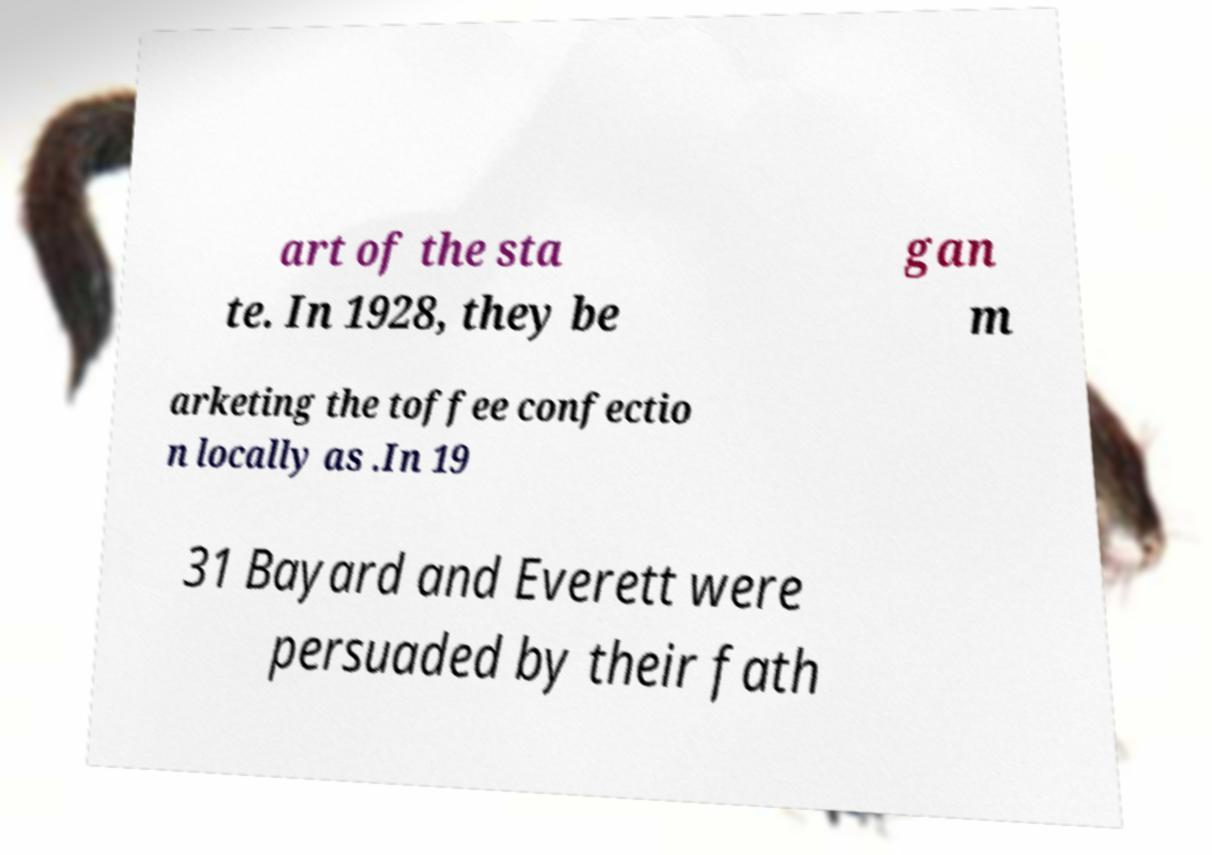Can you accurately transcribe the text from the provided image for me? art of the sta te. In 1928, they be gan m arketing the toffee confectio n locally as .In 19 31 Bayard and Everett were persuaded by their fath 